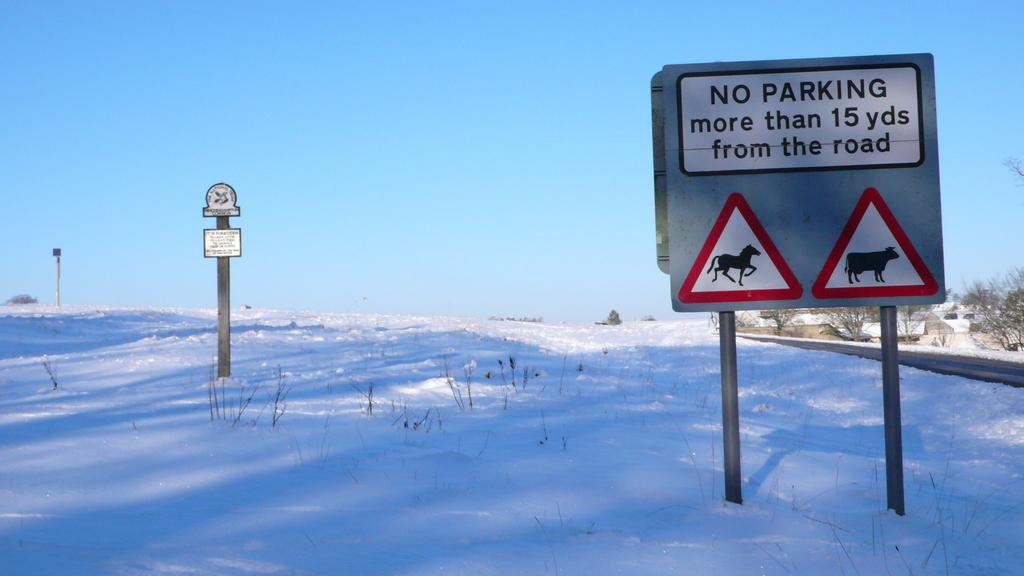<image>
Give a short and clear explanation of the subsequent image. A sign half buried in snow that says no parking more than 15 yards from the road. 